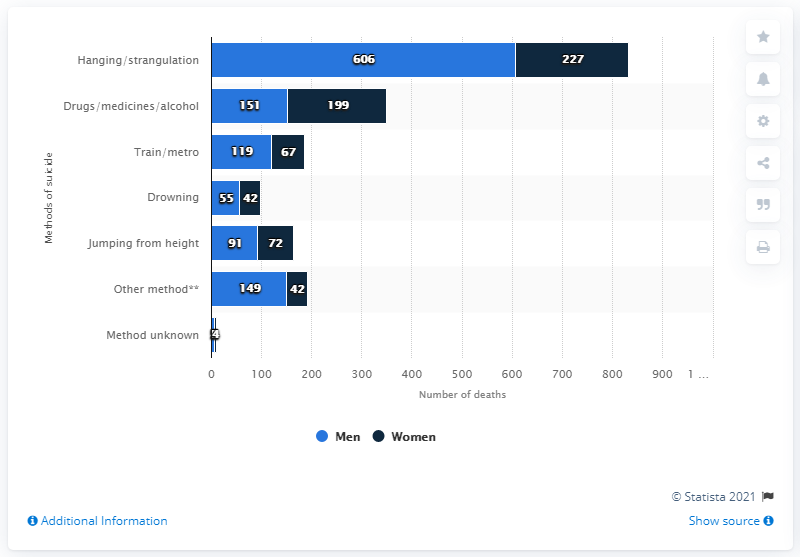Draw attention to some important aspects in this diagram. The highest value in the blue bar is 606. The average of the first, second, and third highest values in the blue bar is 302. 